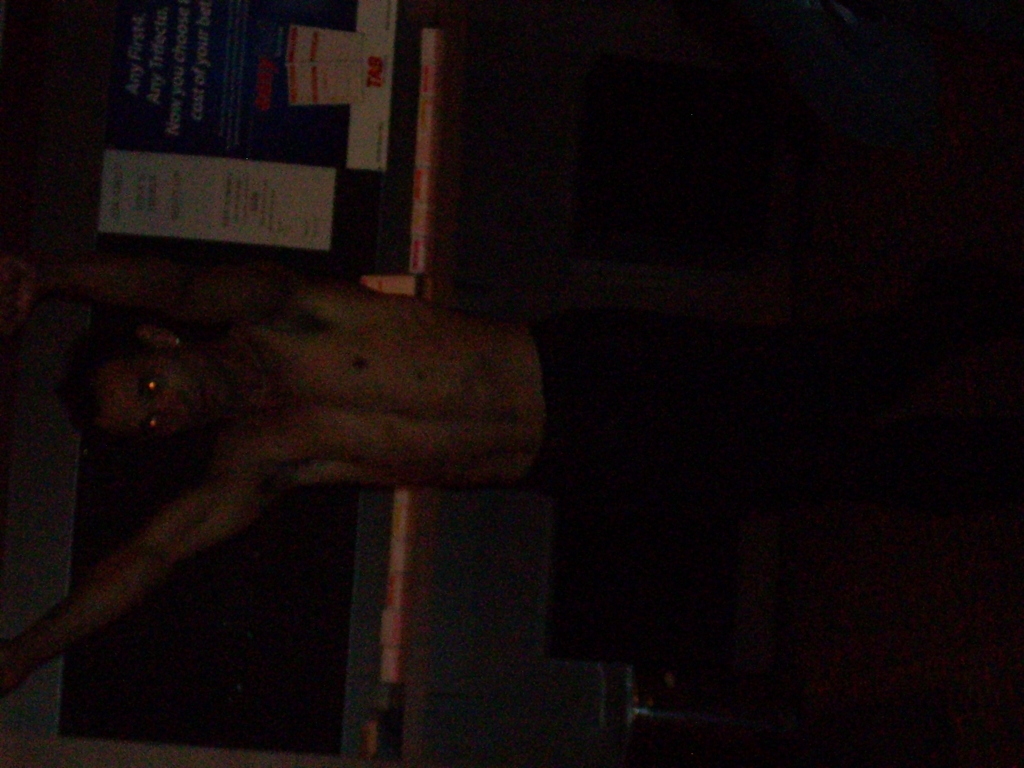Could you describe the color palette and lighting used in this image? The image primarily features a dark color palette with low lighting, which creates a shadowy and somewhat mysterious atmosphere. There appears to be a single light source from above or the side, as indicated by the highlights on the person's body, which add a bit of warm tone to otherwise cooler, subdued hues. How could the photo's composition be improved? Improving the photo's composition could involve increasing the lighting to bring out more details, especially across the subject's features and the background. Additionally, adjusting the angle to avoid tilting could help with the photo's balance. Employing the rule of thirds to position the subject dynamically within the frame could also enhance the overall aesthetic appeal. 